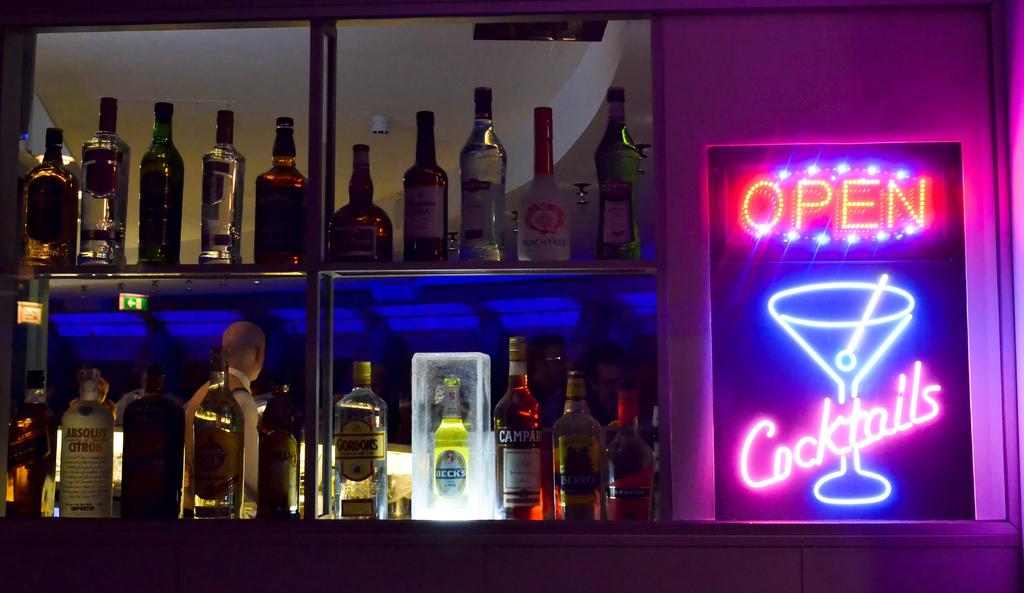What type of drinks are for sale?
Keep it short and to the point. Cocktails. Does the sign say cocktails under the martini drink?
Make the answer very short. Yes. 